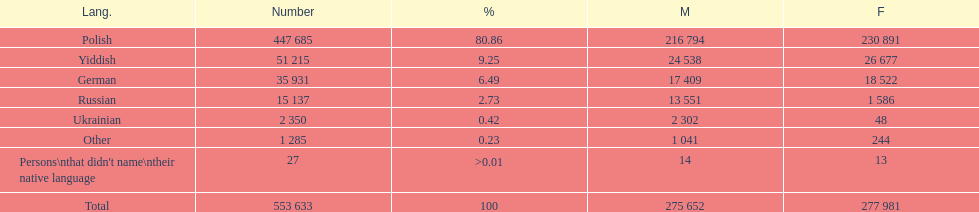Would you mind parsing the complete table? {'header': ['Lang.', 'Number', '%', 'M', 'F'], 'rows': [['Polish', '447 685', '80.86', '216 794', '230 891'], ['Yiddish', '51 215', '9.25', '24 538', '26 677'], ['German', '35 931', '6.49', '17 409', '18 522'], ['Russian', '15 137', '2.73', '13 551', '1 586'], ['Ukrainian', '2 350', '0.42', '2 302', '48'], ['Other', '1 285', '0.23', '1 041', '244'], ["Persons\\nthat didn't name\\ntheir native language", '27', '>0.01', '14', '13'], ['Total', '553 633', '100', '275 652', '277 981']]} How many people didn't name their native language? 27. 